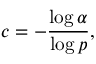Convert formula to latex. <formula><loc_0><loc_0><loc_500><loc_500>c = - { \frac { \log \alpha } { \log p } } ,</formula> 